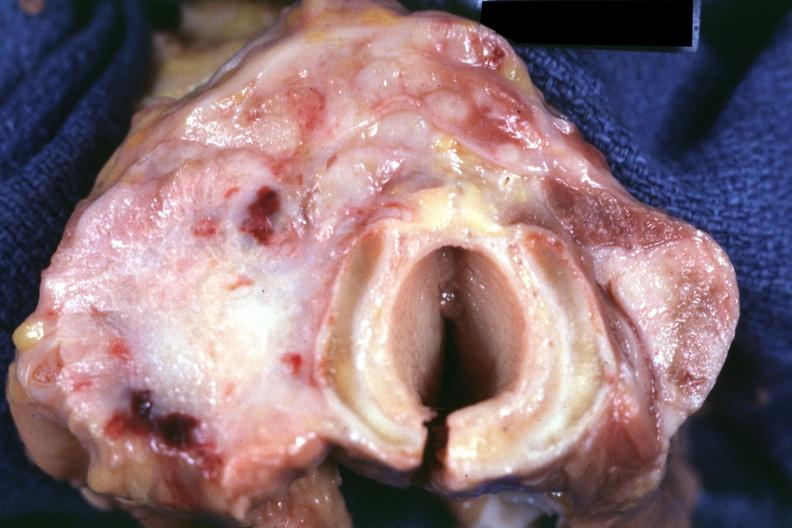what is carcinoma had?
Answer the question using a single word or phrase. Metastases to lungs 